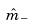<formula> <loc_0><loc_0><loc_500><loc_500>\hat { m } _ { - }</formula> 